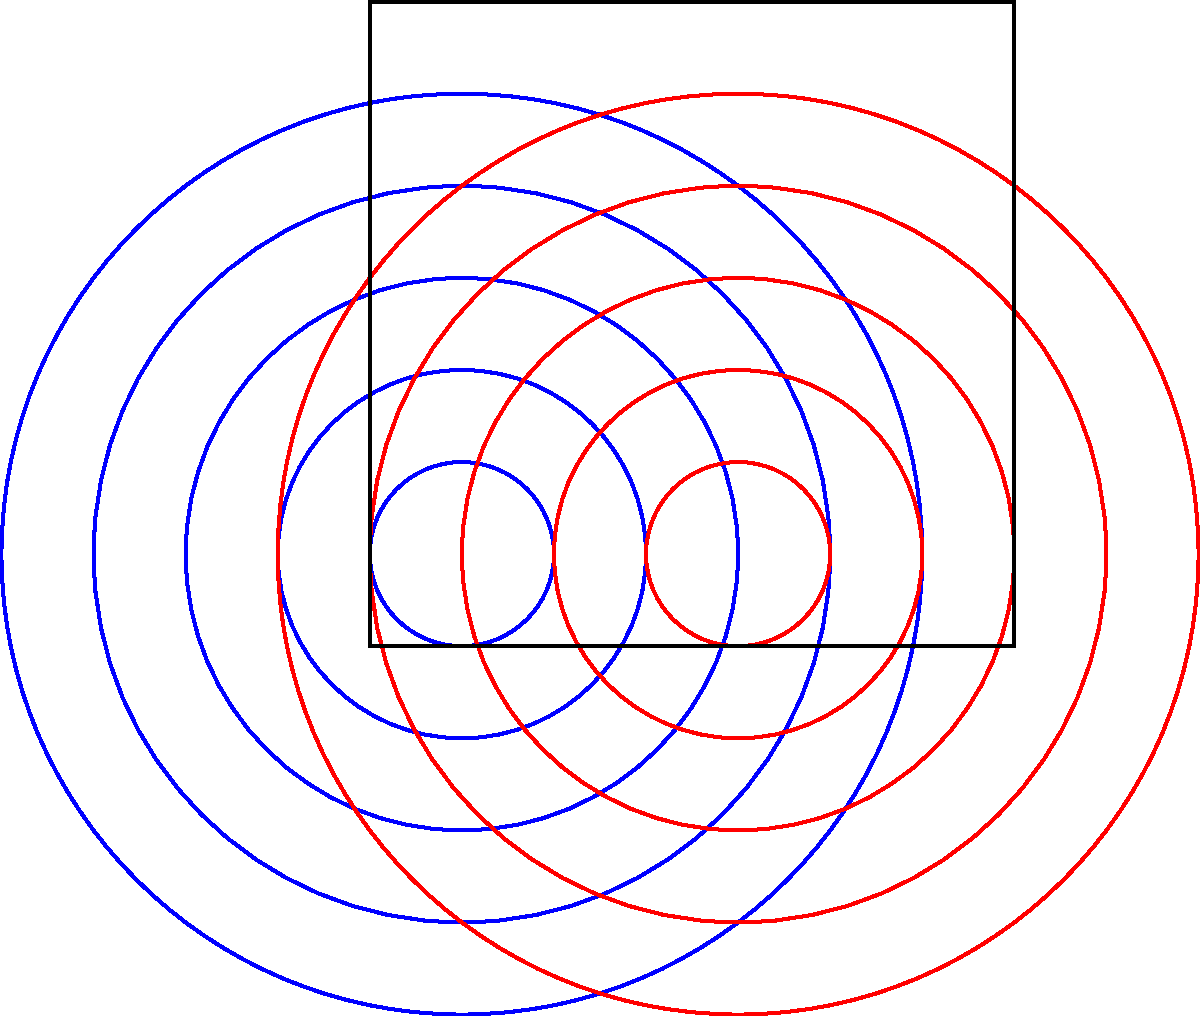In the context of wave interference patterns, consider two point sources emitting coherent waves as shown in the diagram. The blue and red concentric circles represent wavefronts from each source. At which points would you expect to observe constructive interference, and how might this relate to the concept of social reinforcement in voter behavior? To understand the interference pattern and relate it to social reinforcement in voter behavior, let's follow these steps:

1. Wave interference basics:
   - Constructive interference occurs when waves are in phase (crest meets crest).
   - Destructive interference occurs when waves are out of phase (crest meets trough).

2. Identifying constructive interference points:
   - Look for intersections of circles of the same color (same phase) from both sources.
   - These points form hyperbolic curves.

3. Mathematical representation:
   - The path difference between waves from two sources must be an integer multiple of the wavelength for constructive interference.
   - Mathematically: $|r_1 - r_2| = n\lambda$, where $r_1$ and $r_2$ are distances from the sources, $n$ is an integer, and $\lambda$ is the wavelength.

4. Relating to voter behavior:
   - Constructive interference points represent areas of strong reinforcement, similar to how social networks can amplify certain political views.
   - The hyperbolic pattern of these points suggests that influence isn't uniform but varies based on "distance" from information sources.

5. Sociological interpretation:
   - Just as wave interference creates a complex pattern, societal factors create a complex landscape of voter behavior.
   - The interference pattern shows how multiple sources (like media and personal networks) can combine to create areas of strong influence (constructive interference) and areas of conflicting messages (destructive interference).

6. Critical analysis:
   - While this model provides a visual analogy, it's important to note that human behavior is more complex than wave physics.
   - Societal factors like education, economic status, and cultural background would be represented by additional "sources" in this model, creating an even more intricate interference pattern.
Answer: Constructive interference occurs at hyperbolic curves where path difference equals integer multiples of wavelength, analogous to reinforced social influences in voter behavior. 